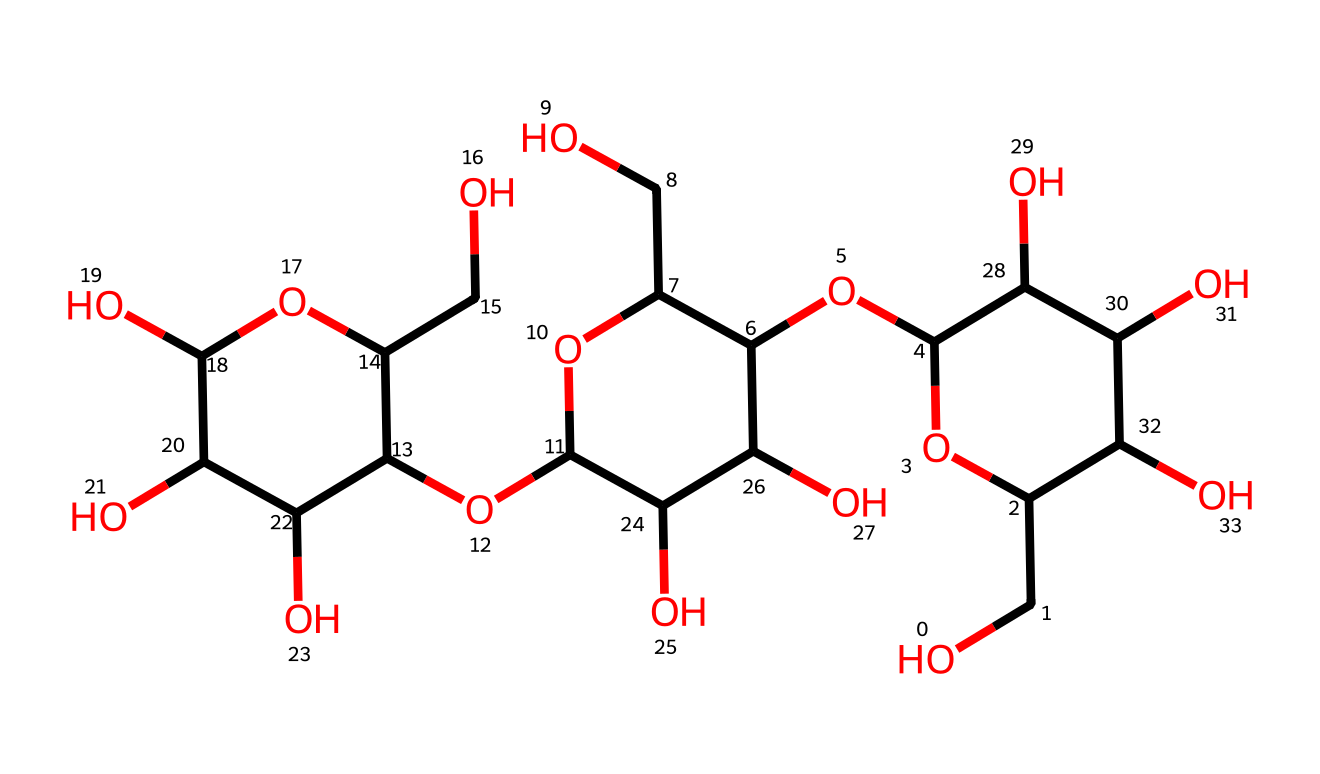how many carbon atoms are in this chemical structure? To determine the number of carbon atoms, we can examine the SMILES representation, counting all the carbon (C) symbols present. The structure indicates multiple carbon atoms connected to various functional groups. A careful count shows that there are 12 carbon atoms in total.
Answer: 12 what is the molecular formula of this compound? The molecular formula can be derived by counting the elements based on the SMILES. The structure indicates there are 12 carbon (C), 22 hydrogen (H), and 11 oxygen (O) atoms. Therefore, the molecular formula can be represented as C12H22O11.
Answer: C12H22O11 what type of polymer is represented by this chemical structure? This chemical structure represents a polysaccharide, specifically cellulose, which is a linear polymer of glucose units. The presence of multiple glucose rings and ether linkages confirms its classification as a polysaccharide.
Answer: polysaccharide what functional groups are present in the chemical structure? The chemical exhibits multiple hydroxyl (-OH) functional groups due to the presence of multiple alcohol units. By examining the chemical closely, we can identify these -OH groups attached to the carbon framework, confirming they are present.
Answer: hydroxyl groups how many hydroxyl groups are in the structure? To count the hydroxyl groups, we analyze the chemical for -OH representations throughout the structure. Each connected -OH indicates a hydroxyl group, and upon careful examination, we find there are 6 -OH groups.
Answer: 6 what is the role of cellulose in plants? Cellulose serves a structural role in plants, providing rigidity and strength to cell walls. Its linear and fibrous structure contributes to the mechanical stability of various plant tissues and cells.
Answer: structural support what is the significance of the glycosidic linkages in this molecule? Glycosidic linkages are essential for connecting glucose units in cellulose, allowing the formation of long chains. These linkages determine the polymer's characteristics, such as its insolubility and high tensile strength, which are vital for plant cell structure.
Answer: chain formation 